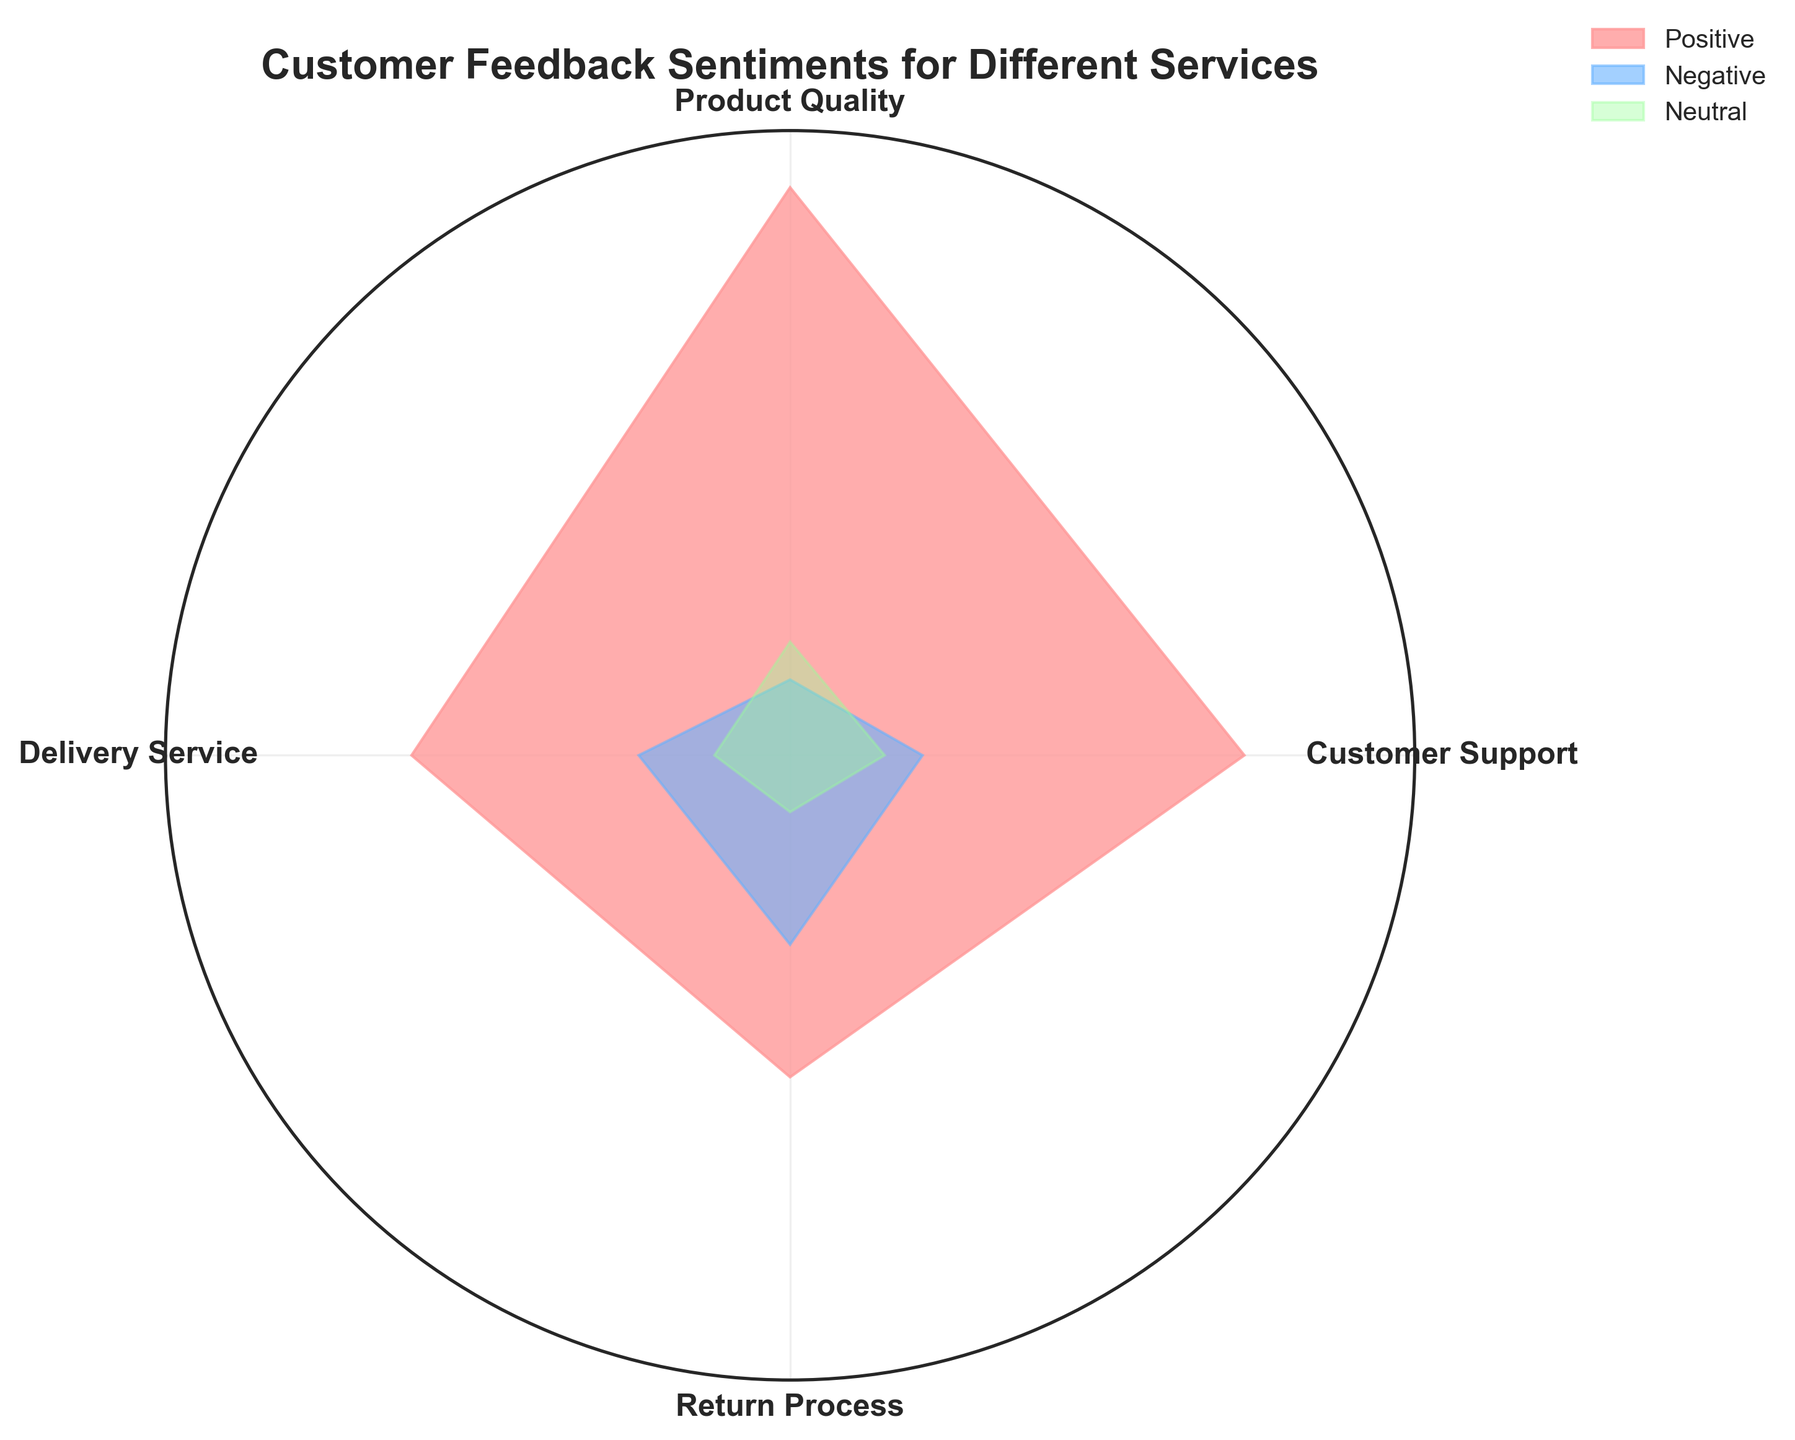What is the title of the chart? The title is prominently displayed at the top of the chart. It reads "Customer Feedback Sentiments for Different Services".
Answer: Customer Feedback Sentiments for Different Services What are the colors used for the different feedback types? The chart uses specific colors for each feedback type. Positive feedback is in pink, negative feedback is in blue, and neutral feedback is in green.
Answer: Pink (Positive), Blue (Negative), Green (Neutral) Which service received the most positive feedback? By observing the lengths of the segments for positive feedback, the Product Quality service has the longest segment.
Answer: Product Quality Which service has the highest count of neutral feedback? By comparing the green-colored segments for neutral feedback, it is evident that Product Quality has the longest segment.
Answer: Product Quality How does the negative feedback for Delivery Service compare to Customer Support? Comparing the blue-colored segments, Delivery Service has a longer segment than Customer Support.
Answer: Greater than Customer Support What is the difference in neutral feedback between Product Quality and Return Process? By comparing the segment lengths, Product Quality has 30 neutral feedback while Return Process has 15. The difference is 30 - 15.
Answer: 15 Arrange the services in descending order based on positive feedback. Observing the pink-colored segments, they are in the following order: Product Quality (150), Customer Support (120), Delivery Service (100), Return Process (85).
Answer: Product Quality, Customer Support, Delivery Service, Return Process Which service has the smallest variance in feedback sentiments (i.e., the similar lengths for positive, negative, and neutral segments)? By analyzing the chart, Customer Support has more balanced feedback for all three sentiments compared to the other services.
Answer: Customer Support Which two services have the closest amount of negative feedback? Comparing the blue-colored segments, Customer Support (35) and Delivery Service (40) have the closest values.
Answer: Customer Support and Delivery Service 